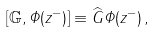Convert formula to latex. <formula><loc_0><loc_0><loc_500><loc_500>[ \mathbb { G } , { \mathit \Phi } ( z ^ { - } ) ] \equiv \widehat { G } { \mathit \Phi } ( z ^ { - } ) \, ,</formula> 